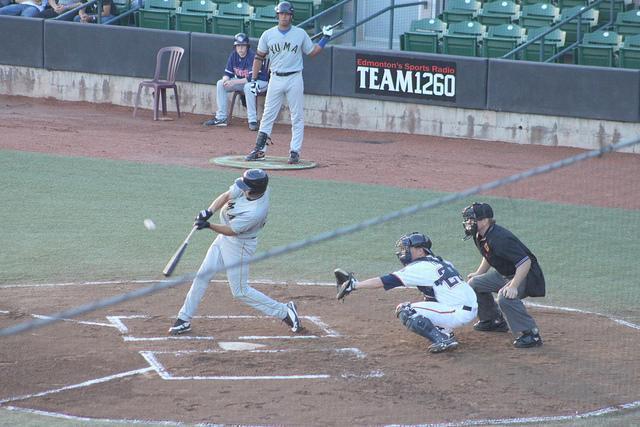What province is this located?
Select the accurate answer and provide justification: `Answer: choice
Rationale: srationale.`
Options: Ontario, alberta, pei, bc. Answer: alberta.
Rationale: The radio station is in edmonton, which is in this province. 